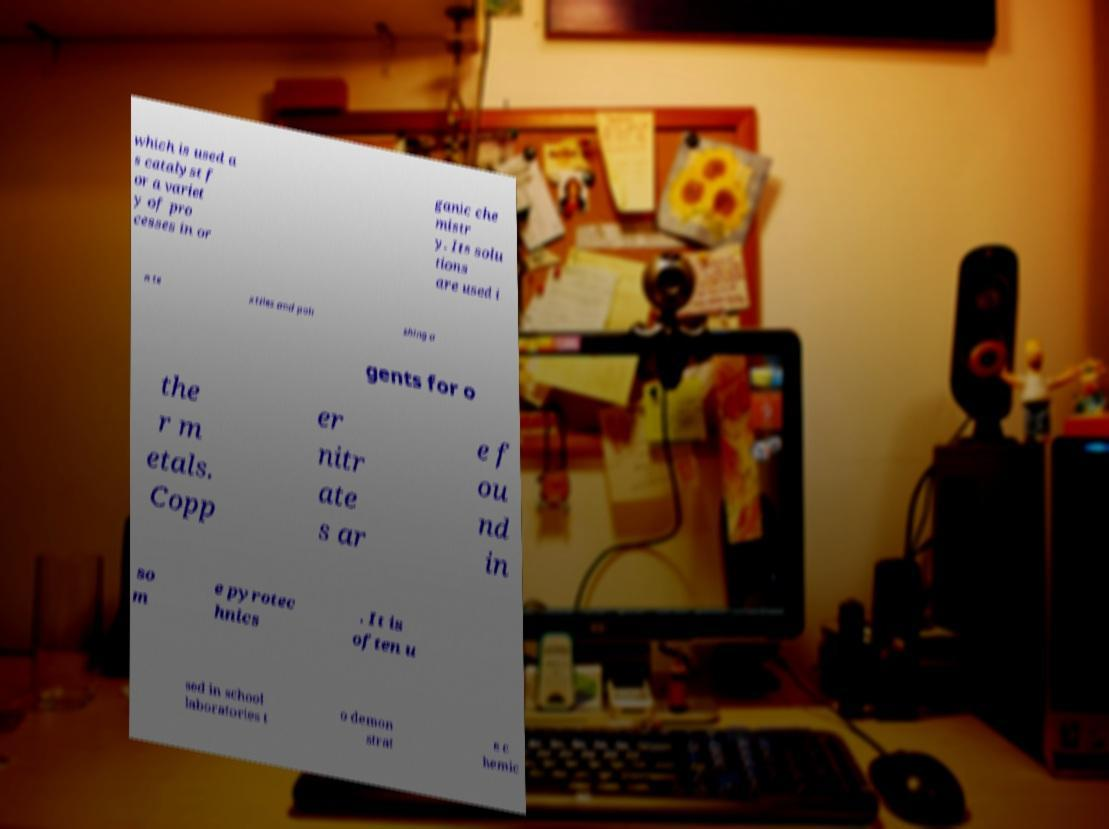Could you extract and type out the text from this image? which is used a s catalyst f or a variet y of pro cesses in or ganic che mistr y. Its solu tions are used i n te xtiles and poli shing a gents for o the r m etals. Copp er nitr ate s ar e f ou nd in so m e pyrotec hnics . It is often u sed in school laboratories t o demon strat e c hemic 